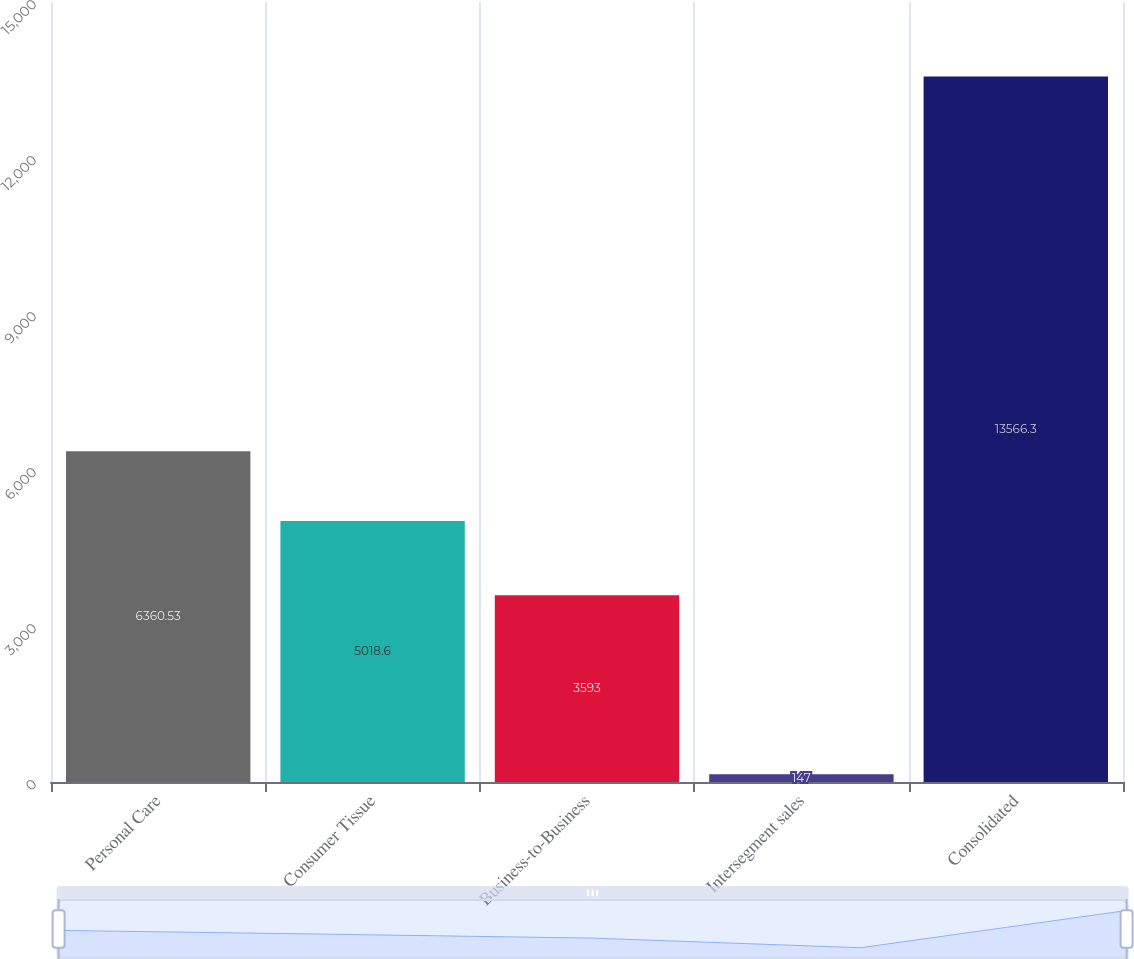<chart> <loc_0><loc_0><loc_500><loc_500><bar_chart><fcel>Personal Care<fcel>Consumer Tissue<fcel>Business-to-Business<fcel>Intersegment sales<fcel>Consolidated<nl><fcel>6360.53<fcel>5018.6<fcel>3593<fcel>147<fcel>13566.3<nl></chart> 